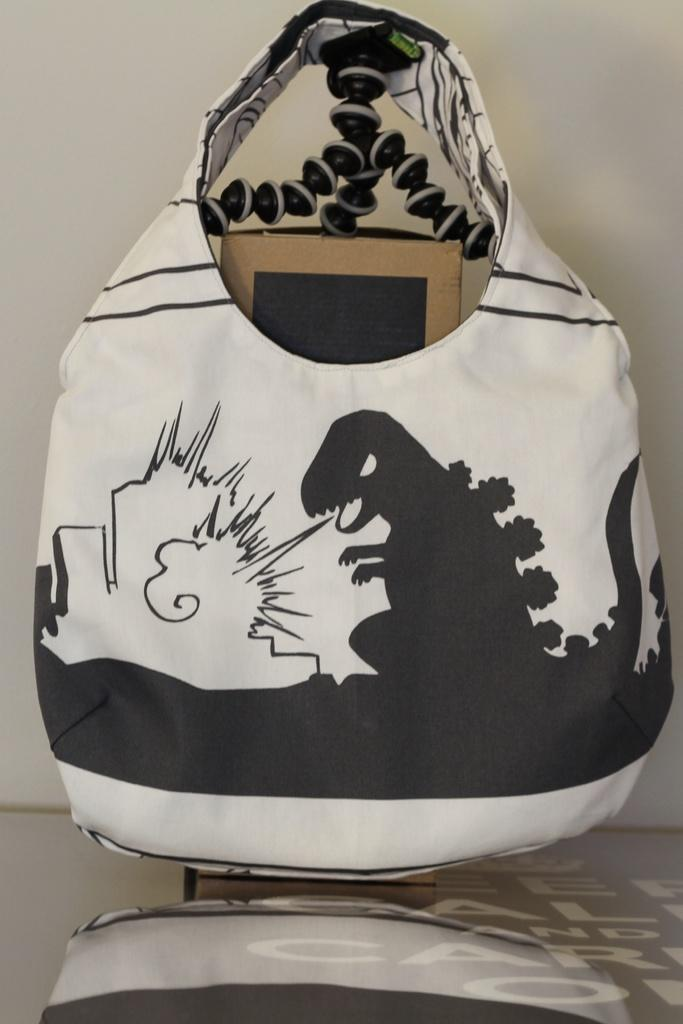What is depicted on the bag in the image? There is a dinosaur picture on the bag. What can be found inside the bag? There is a box inside the bag. Where is the bag located in the image? The bag is placed on a table. What is visible on the table's surface due to the bag's presence? There is a reflection of the bag on the table. What type of rice is being served on the throne in the image? There is no throne or rice present in the image; it features a bag with a dinosaur picture on a table. 